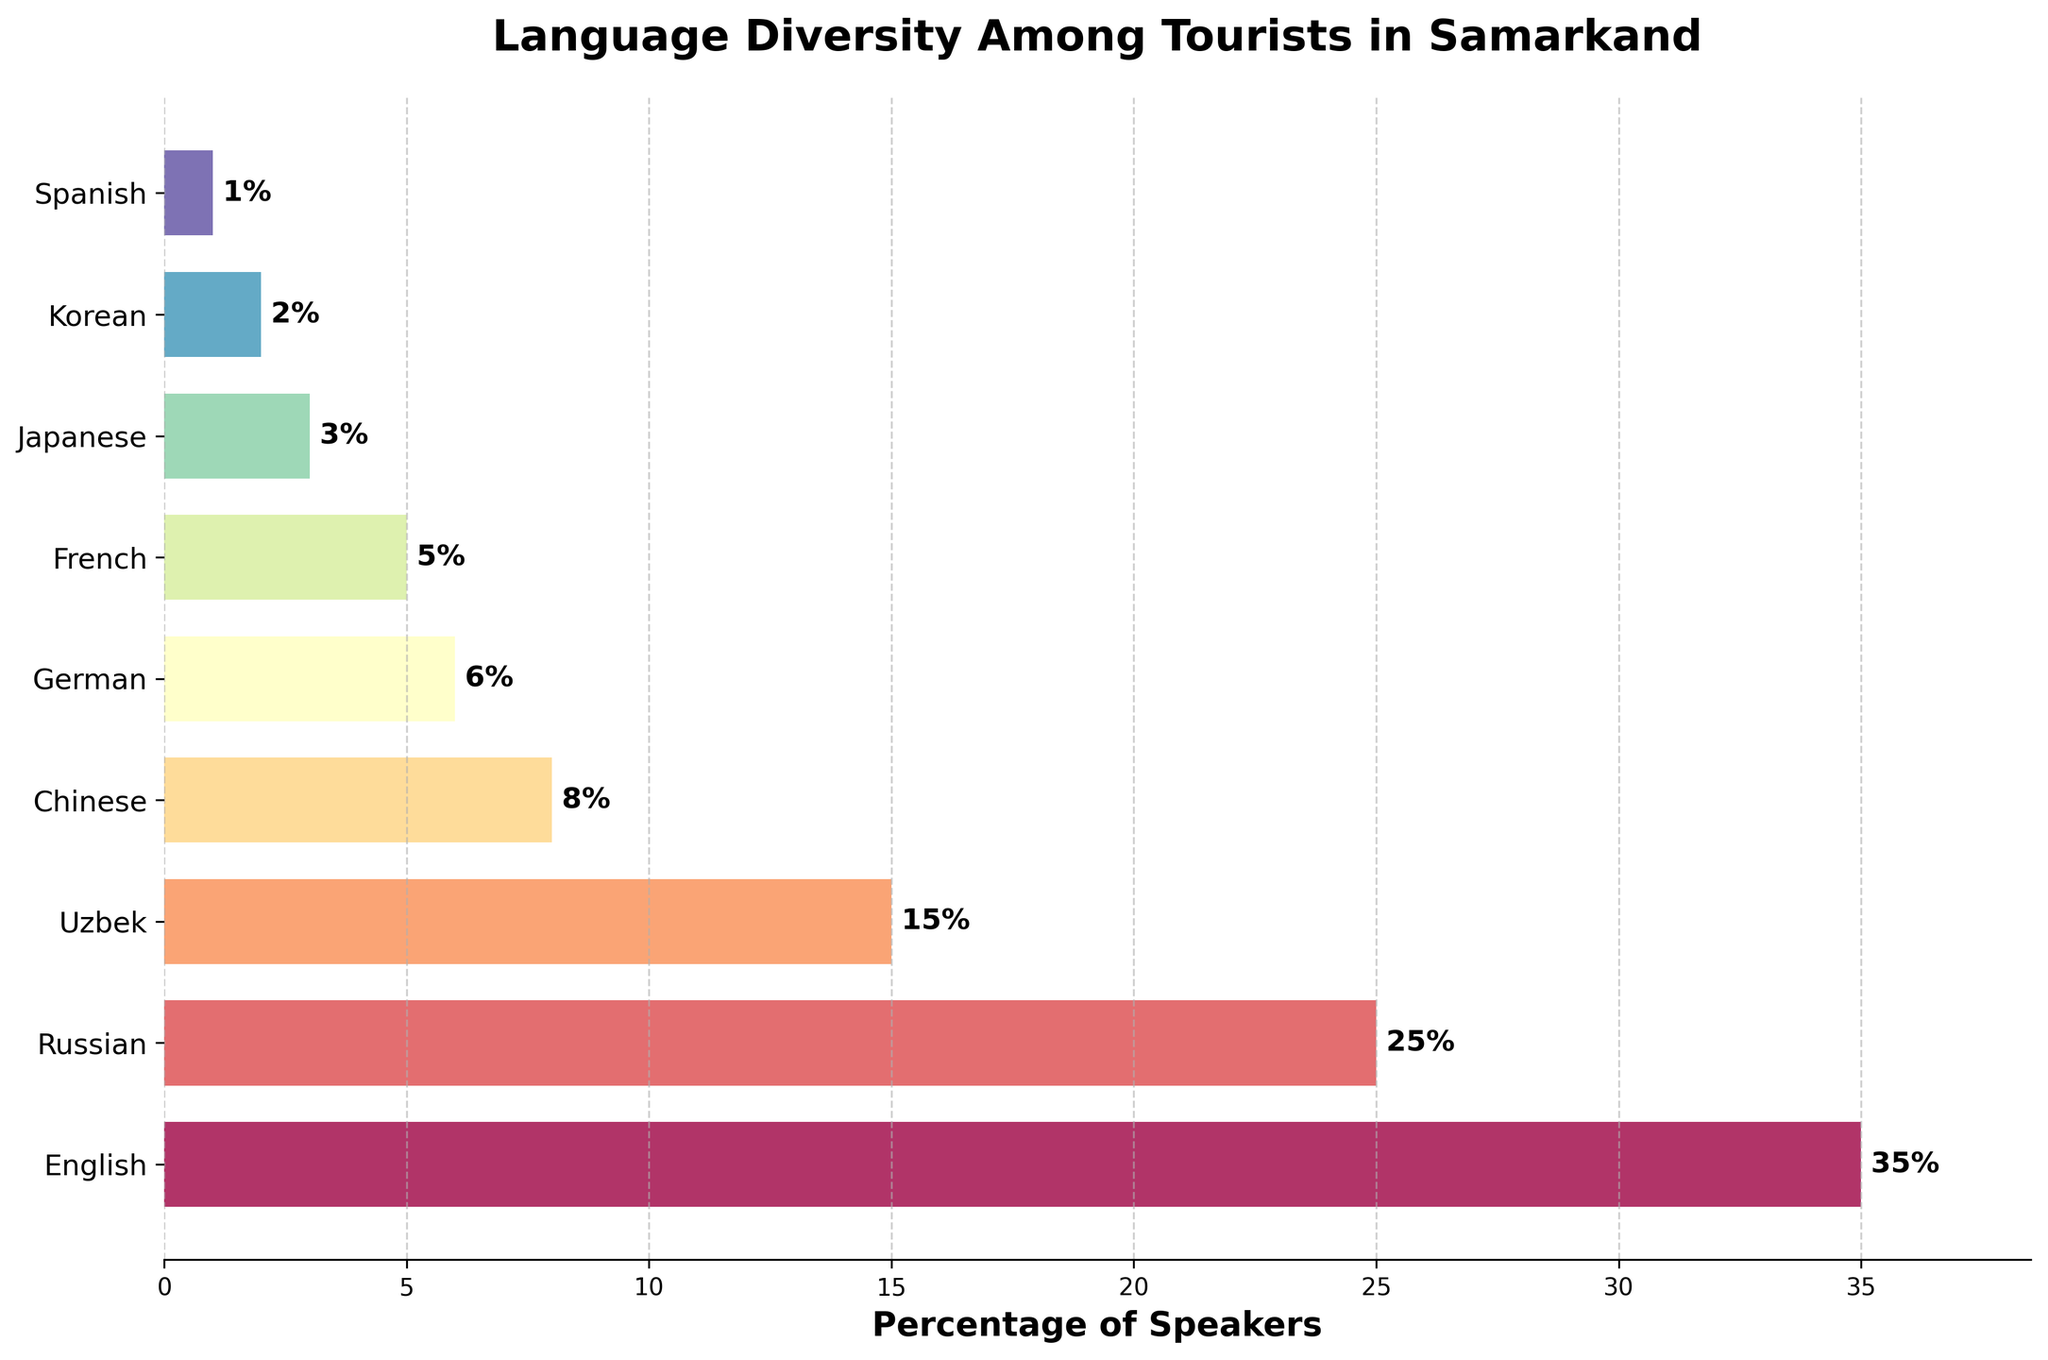What is the title of the plot? The title of the plot is usually located at the top of the figure. From the plot, we can clearly see that it says "Language Diversity Among Tourists in Samarkand."
Answer: Language Diversity Among Tourists in Samarkand Which language has the highest percentage of speakers? To determine this, we look for the longest bar in the horizontal bar plot. The longest bar corresponds to English, with a percentage of 35%.
Answer: English What is the combined percentage of Russian and Uzbek speakers? We add the percentages of Russian and Uzbek speakers together. Russian speakers are 25% and Uzbek speakers are 15%, so the combined percentage is 25% + 15% = 40%.
Answer: 40% How does the percentage of German speakers compare to the percentage of French speakers? To compare these, we look at the lengths of the bars corresponding to German and French. German has 6% and French has 5%. Thus, German has a slightly higher percentage of speakers than French.
Answer: German has a higher percentage Which language has the smallest percentage of speakers? We identify the shortest bar in the horizontal bar plot. The shortest bar corresponds to Spanish, with a percentage of 1%.
Answer: Spanish What is the total percentage of Asian languages (Chinese, Japanese, and Korean) represented? We sum up the percentages of Chinese, Japanese, and Korean speakers. Chinese has 8%, Japanese has 3%, and Korean has 2%. So, the total percentage is 8% + 3% + 2% = 13%.
Answer: 13% Is the percentage of Russian speakers greater or less than the combined percentage of French and Japanese speakers? First, we find the combined percentage of French and Japanese speakers, which is 5% + 3% = 8%. Then we compare this to the Russian speakers, which is 25%. Since 25% is greater than 8%, the percentage of Russian speakers is greater.
Answer: Greater What percentage of speakers does the second most common language represent? The second longest bar represents Russian speakers, with a percentage of 25%.
Answer: 25% How many languages have a percentage of speakers greater than or equal to 10%? By examining the plot, we find that the languages with percentages greater than or equal to 10% are English (35%), Russian (25%), and Uzbek (15%). These are exactly three languages.
Answer: 3 What is the average percentage of the least common three languages (Japanese, Korean, Spanish)? We sum the percentages of Japanese, Korean, and Spanish speakers (3%, 2%, and 1%) and divide by 3. The sum is 3% + 2% + 1% = 6%, and the average is 6% / 3 = 2%.
Answer: 2% 